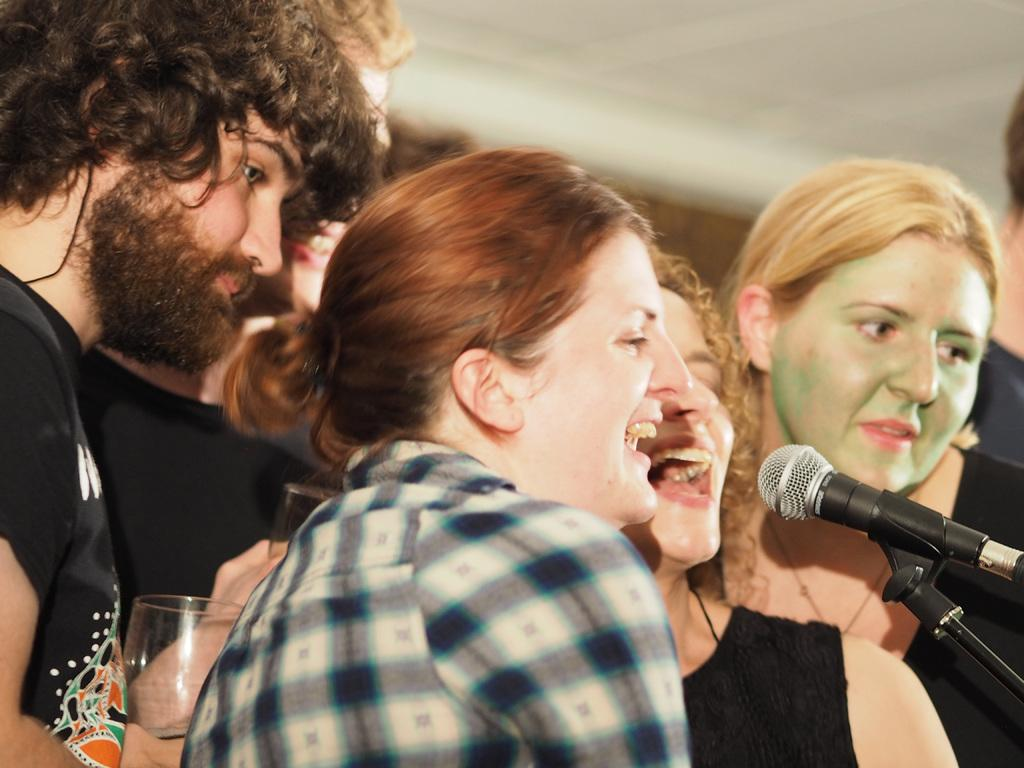How many people are in the group that is visible in the image? There is a group of people in the image, but the exact number is not specified. What are some people in the group holding in their hands? Some people in the group are holding glasses in their hands. What object can be seen on the right side of the image? There is a microphone on the right side of the image. What type of drum is being played by the person in the image? There is no drum present in the image; only a group of people, glasses, and a microphone are visible. 